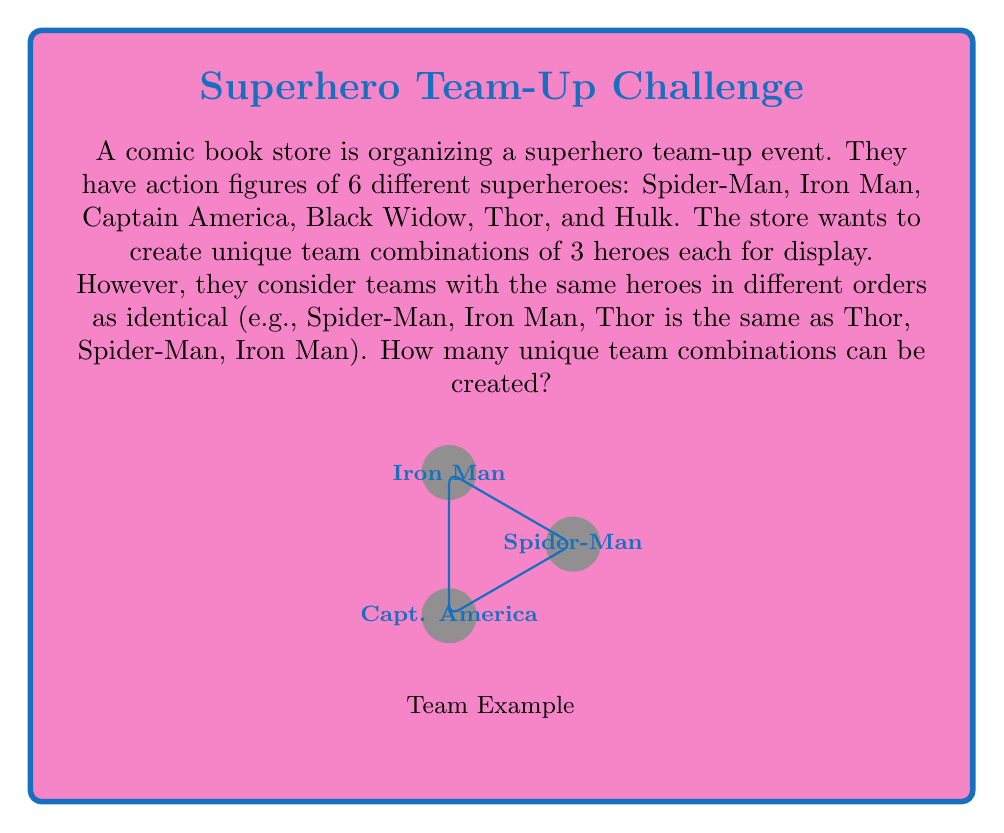Can you solve this math problem? To solve this problem, we need to use the concept of combinations rather than permutations, as the order doesn't matter in this case. We can approach this step-by-step:

1) First, we need to calculate how many ways we can choose 3 heroes out of 6. This is given by the combination formula:

   $$\binom{6}{3} = \frac{6!}{3!(6-3)!} = \frac{6!}{3!3!}$$

2) Let's expand this:
   $$\frac{6 \cdot 5 \cdot 4 \cdot 3!}{3 \cdot 2 \cdot 1 \cdot 3!}$$

3) The 3! cancels out in the numerator and denominator:
   $$\frac{6 \cdot 5 \cdot 4}{3 \cdot 2 \cdot 1}$$

4) Now let's multiply:
   $$\frac{120}{6} = 20$$

Therefore, there are 20 unique team combinations that can be created.

This problem relates to permutation groups because we're essentially looking at the orbits of the action of the symmetric group $S_3$ (permutations of 3 elements) on the set of all 3-element subsets of our 6 heroes. Each orbit represents a unique team, regardless of the order of its members.
Answer: 20 unique team combinations 